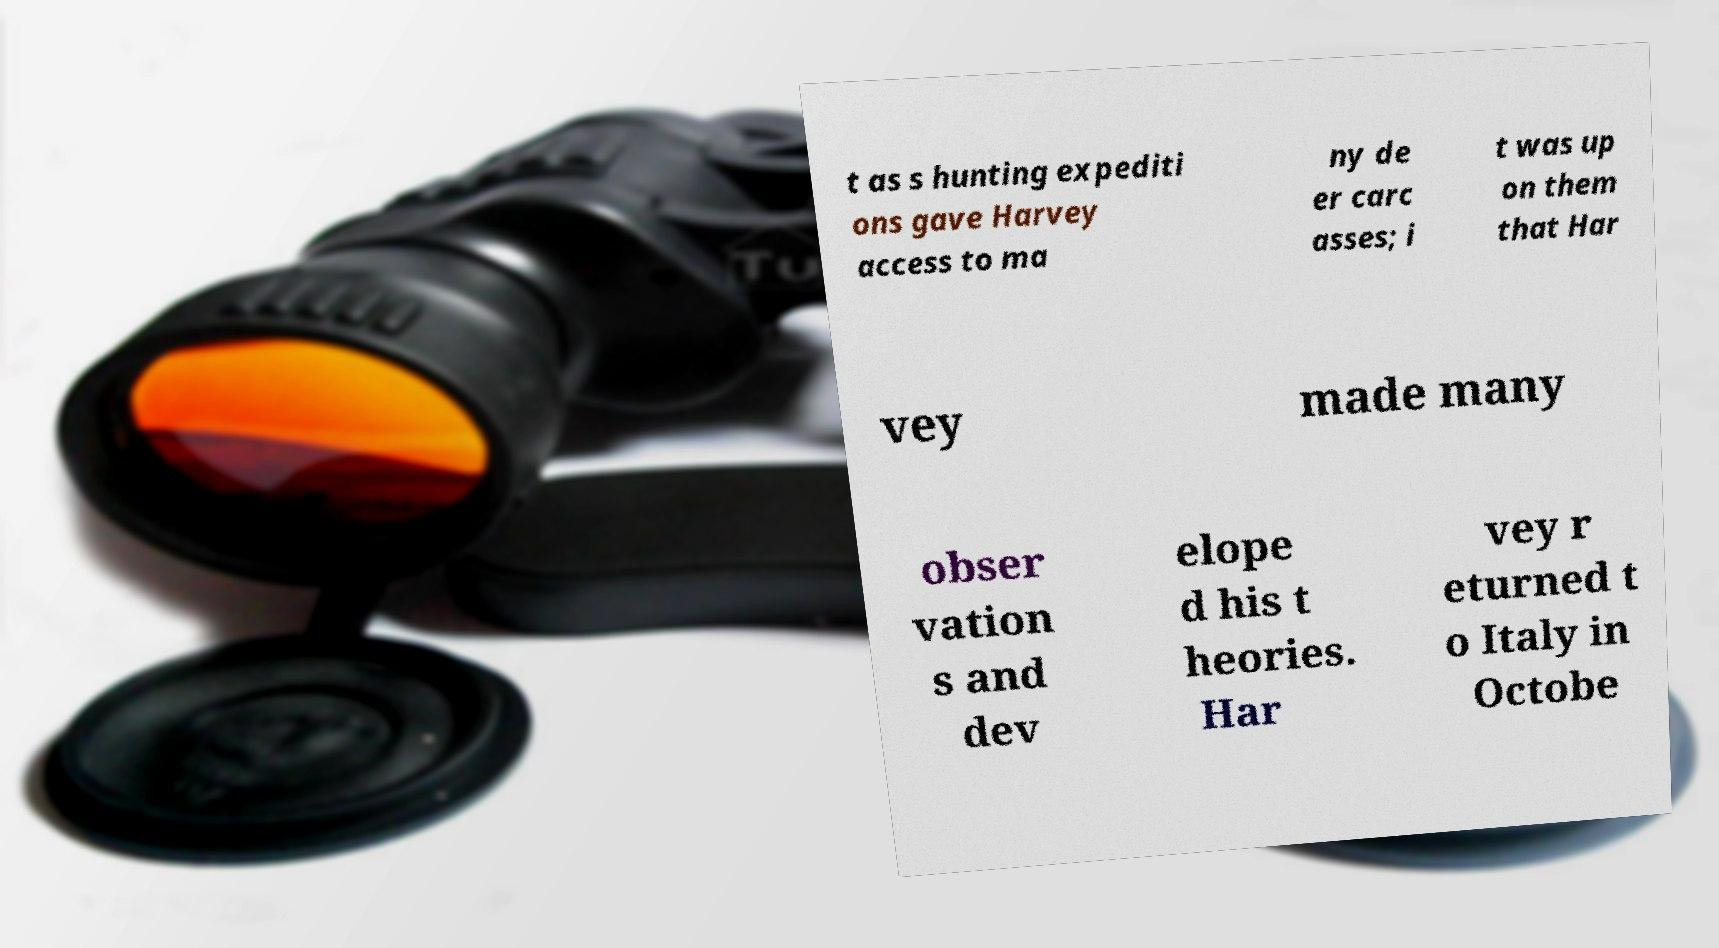There's text embedded in this image that I need extracted. Can you transcribe it verbatim? t as s hunting expediti ons gave Harvey access to ma ny de er carc asses; i t was up on them that Har vey made many obser vation s and dev elope d his t heories. Har vey r eturned t o Italy in Octobe 